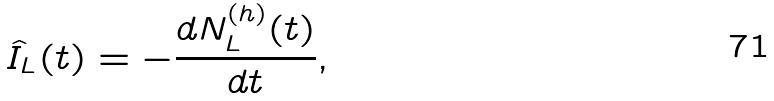<formula> <loc_0><loc_0><loc_500><loc_500>\hat { I } _ { L } ( t ) = - \frac { d N ^ { ( h ) } _ { L } ( t ) } { d t } ,</formula> 